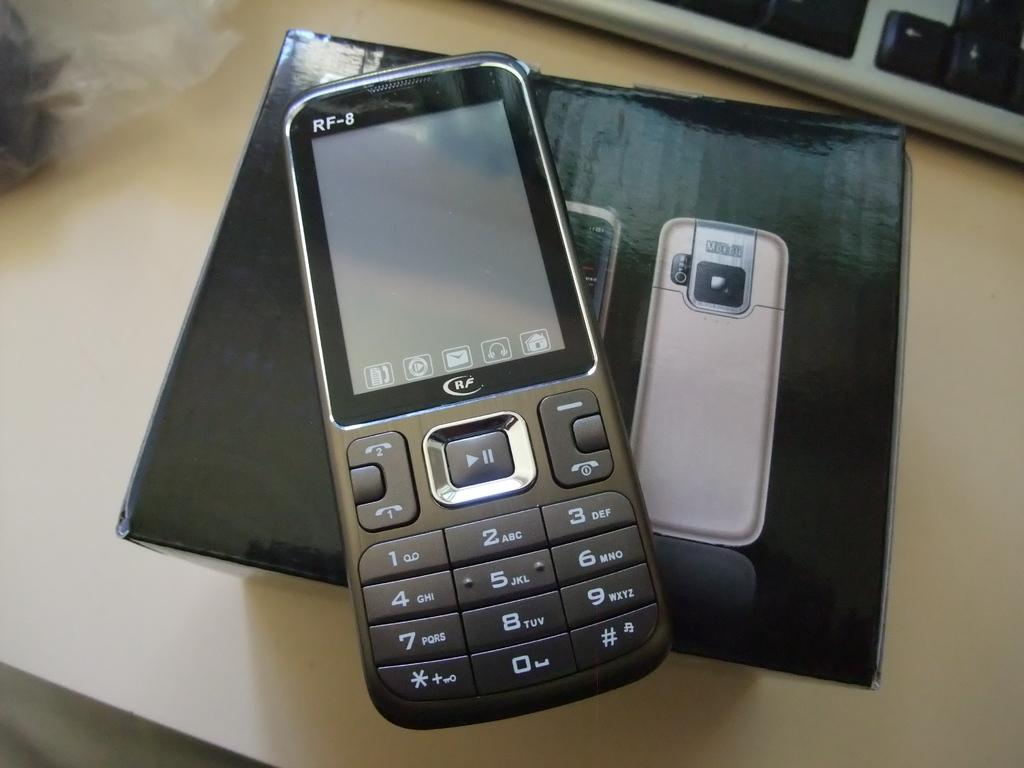<image>
Describe the image concisely. RF 8 black cellphone that shows the home screen 